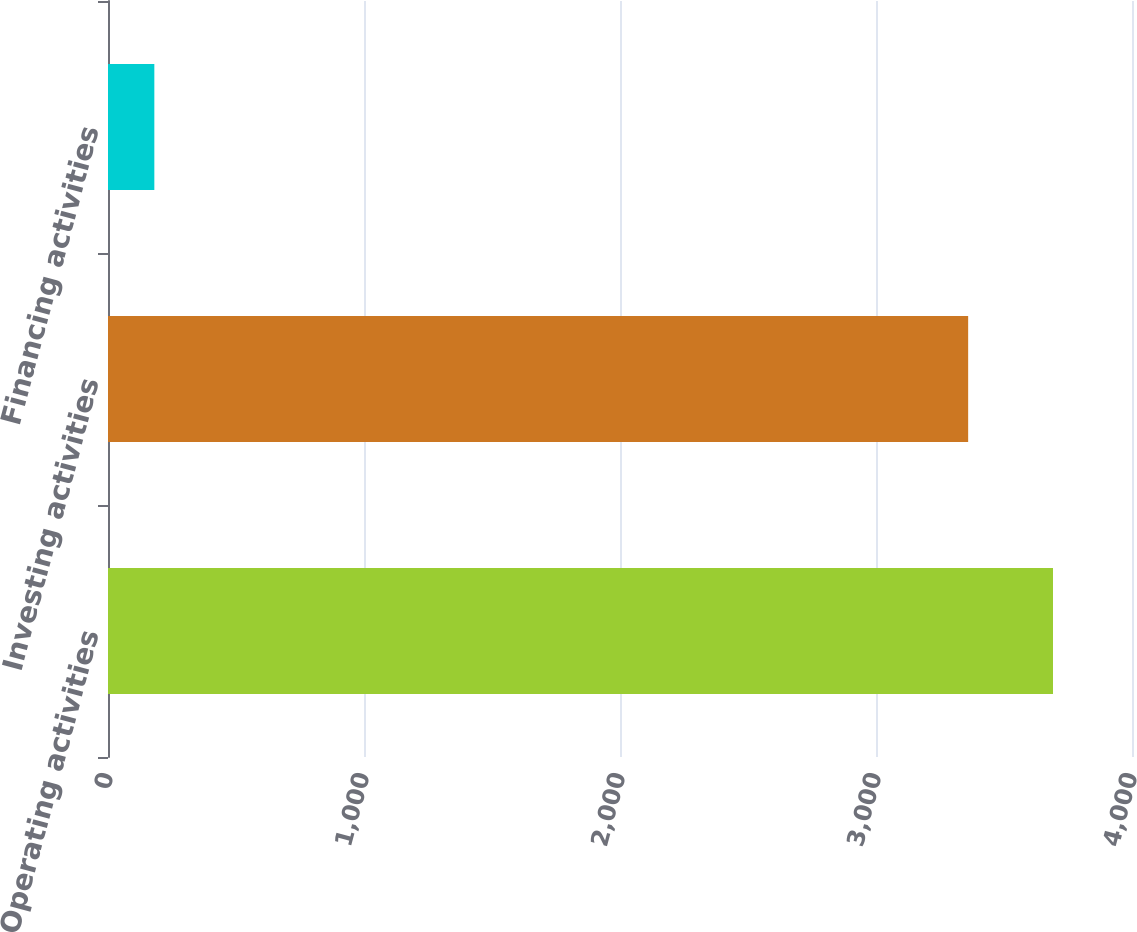Convert chart. <chart><loc_0><loc_0><loc_500><loc_500><bar_chart><fcel>Operating activities<fcel>Investing activities<fcel>Financing activities<nl><fcel>3691.4<fcel>3360<fcel>181<nl></chart> 